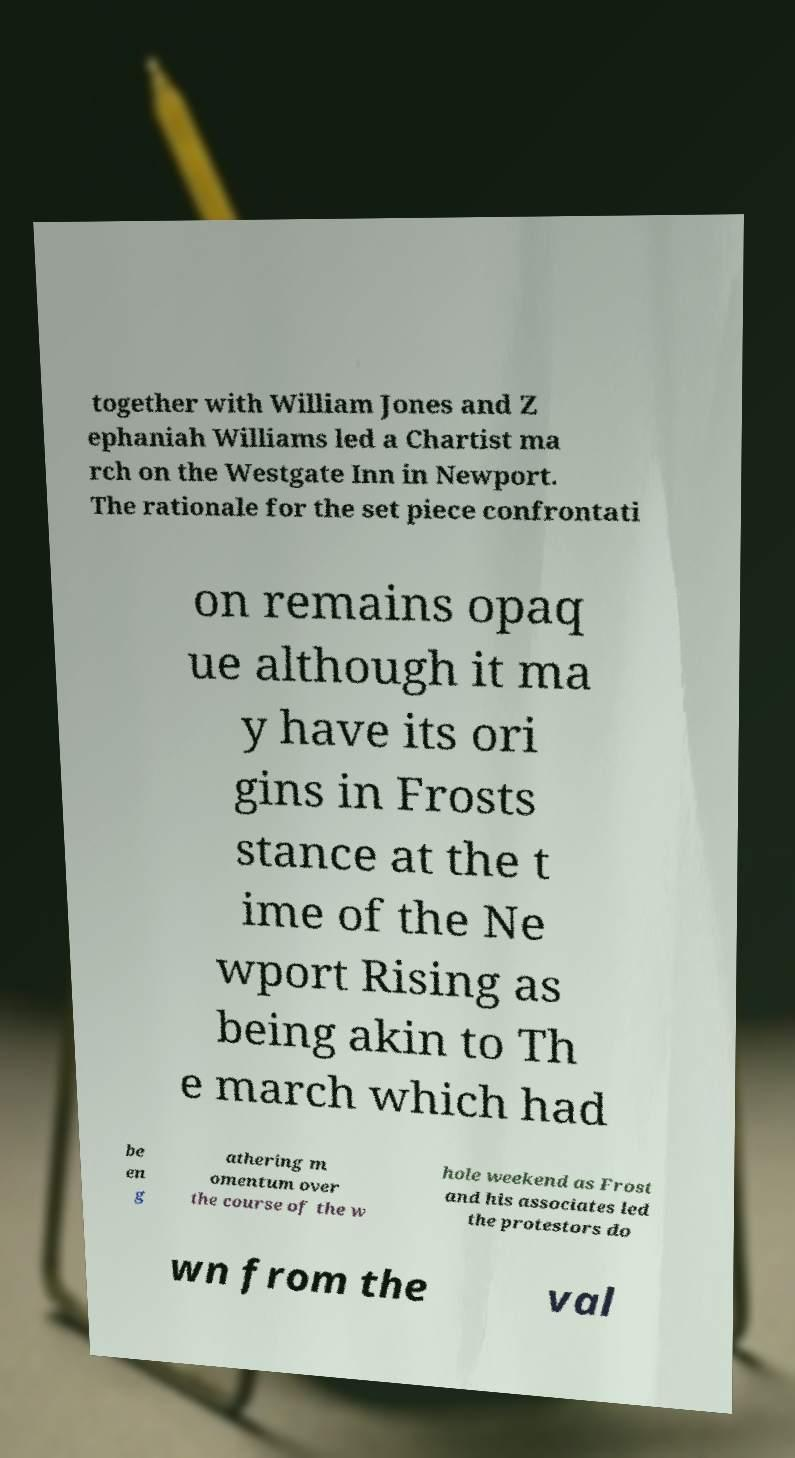Can you read and provide the text displayed in the image?This photo seems to have some interesting text. Can you extract and type it out for me? together with William Jones and Z ephaniah Williams led a Chartist ma rch on the Westgate Inn in Newport. The rationale for the set piece confrontati on remains opaq ue although it ma y have its ori gins in Frosts stance at the t ime of the Ne wport Rising as being akin to Th e march which had be en g athering m omentum over the course of the w hole weekend as Frost and his associates led the protestors do wn from the val 